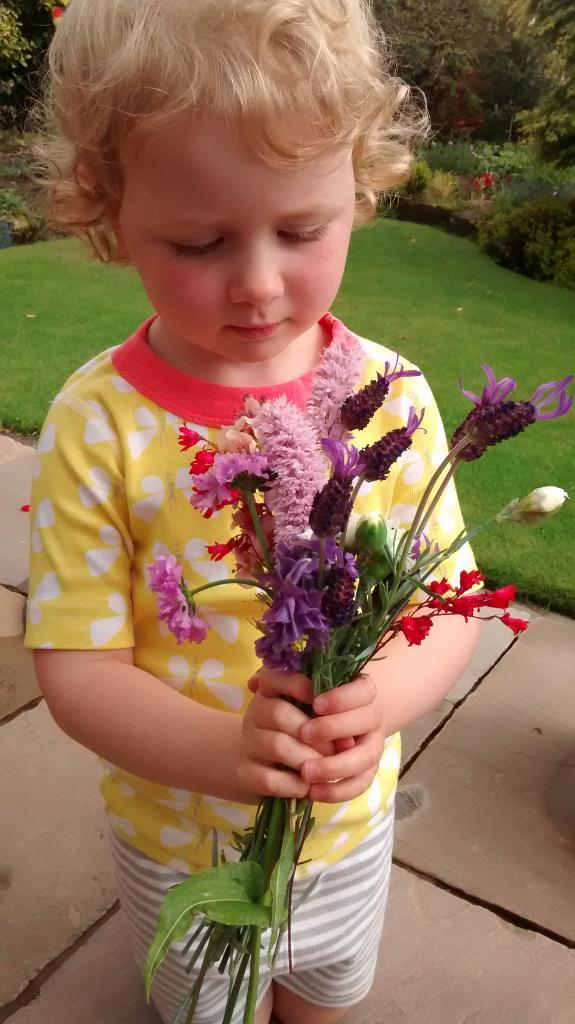What is the main subject of the picture? The main subject of the picture is a kid. What is the kid holding in the picture? The kid is holding a purple flower bouquet. Can you describe the bouquet? The bouquet has green leaves. Where is the kid standing in the picture? The kid is standing on a path. What can be seen around the path? The path is surrounded by grass, and trees are present near the path. How many toes are visible on the kid's feet in the image? The image does not show the kid's feet, so the number of toes cannot be determined. What type of food is the kid eating in the picture? There is no food visible in the image; the kid is holding a purple flower bouquet. 